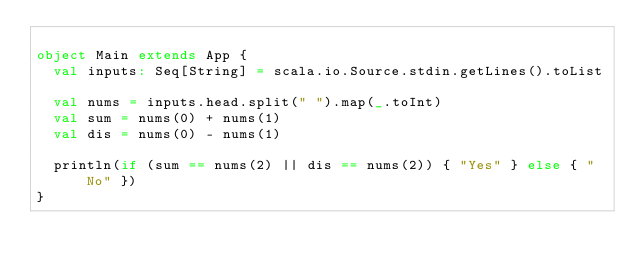<code> <loc_0><loc_0><loc_500><loc_500><_Scala_>
object Main extends App {
  val inputs: Seq[String] = scala.io.Source.stdin.getLines().toList
  
  val nums = inputs.head.split(" ").map(_.toInt)
  val sum = nums(0) + nums(1)
  val dis = nums(0) - nums(1)

  println(if (sum == nums(2) || dis == nums(2)) { "Yes" } else { "No" })
}</code> 